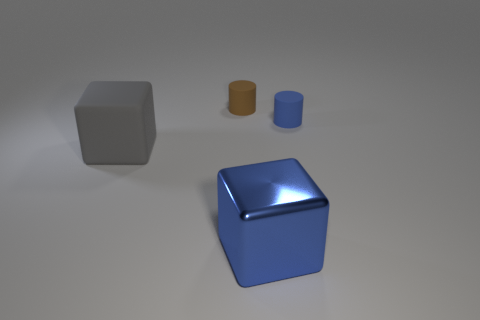Are there any metal cubes that are right of the cylinder right of the small rubber cylinder that is on the left side of the large blue block?
Make the answer very short. No. Are there fewer small things that are in front of the gray rubber thing than gray things that are behind the big blue cube?
Make the answer very short. Yes. What color is the large thing that is made of the same material as the small brown cylinder?
Your answer should be very brief. Gray. There is a matte cylinder behind the blue thing that is to the right of the large blue metallic object; what color is it?
Offer a terse response. Brown. Is there a tiny cylinder that has the same color as the big metal block?
Offer a very short reply. Yes. What shape is the other rubber object that is the same size as the blue rubber object?
Offer a terse response. Cylinder. What number of big gray cubes are in front of the matte object on the left side of the brown rubber object?
Keep it short and to the point. 0. Is the color of the shiny object the same as the big matte object?
Your answer should be very brief. No. What number of other objects are the same material as the big blue object?
Ensure brevity in your answer.  0. There is a large object that is in front of the large thing on the left side of the big blue block; what is its shape?
Your answer should be very brief. Cube. 